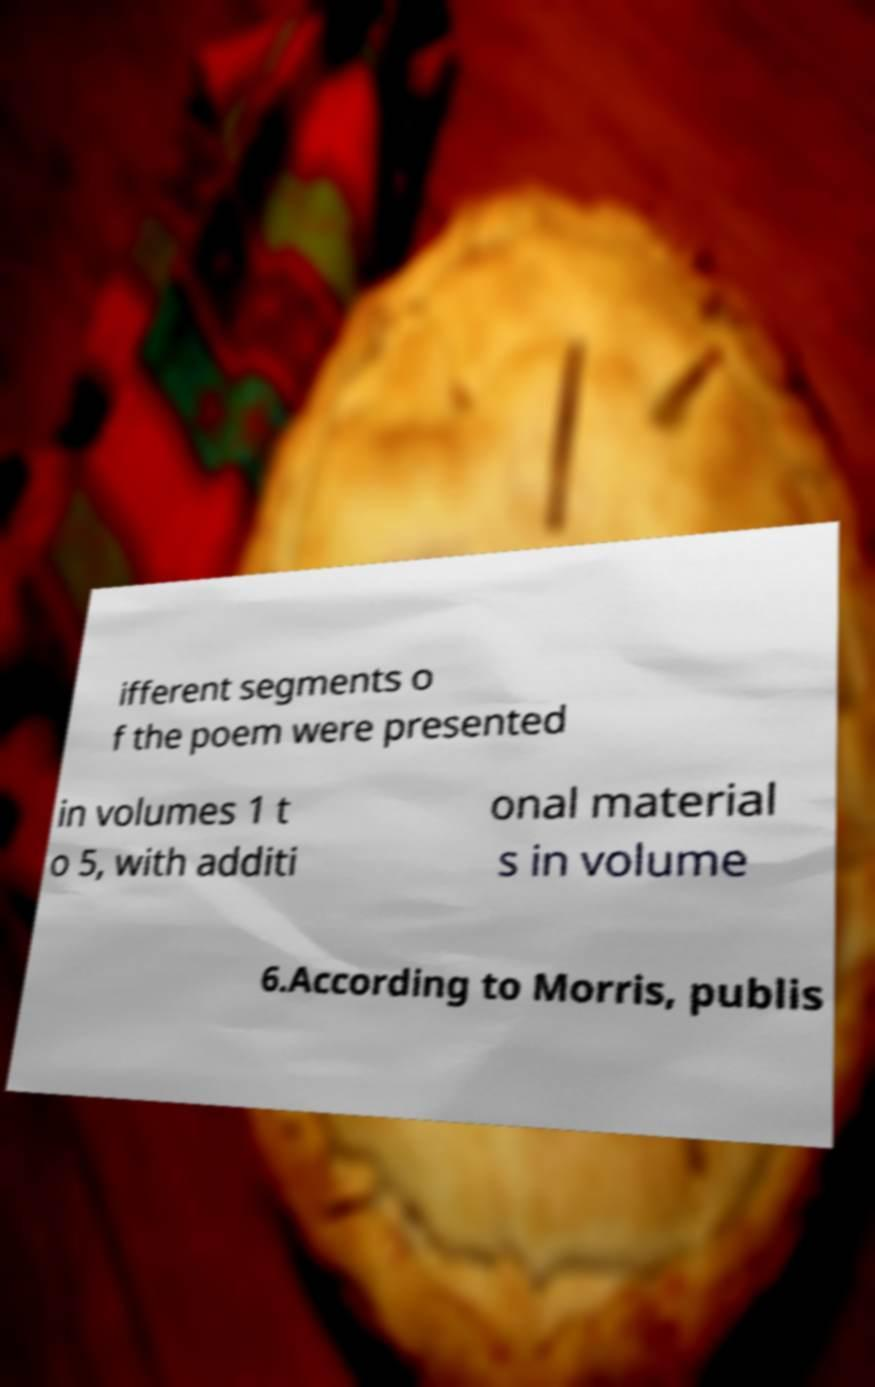Can you accurately transcribe the text from the provided image for me? ifferent segments o f the poem were presented in volumes 1 t o 5, with additi onal material s in volume 6.According to Morris, publis 